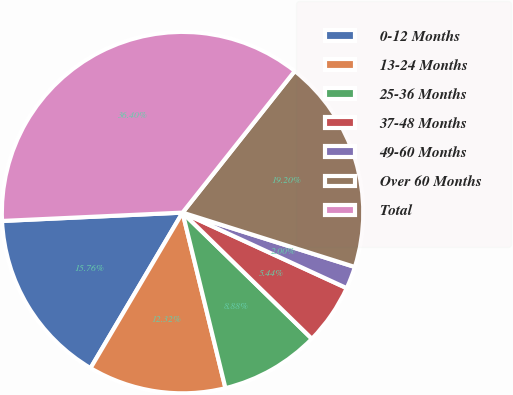Convert chart. <chart><loc_0><loc_0><loc_500><loc_500><pie_chart><fcel>0-12 Months<fcel>13-24 Months<fcel>25-36 Months<fcel>37-48 Months<fcel>49-60 Months<fcel>Over 60 Months<fcel>Total<nl><fcel>15.76%<fcel>12.32%<fcel>8.88%<fcel>5.44%<fcel>2.0%<fcel>19.2%<fcel>36.4%<nl></chart> 